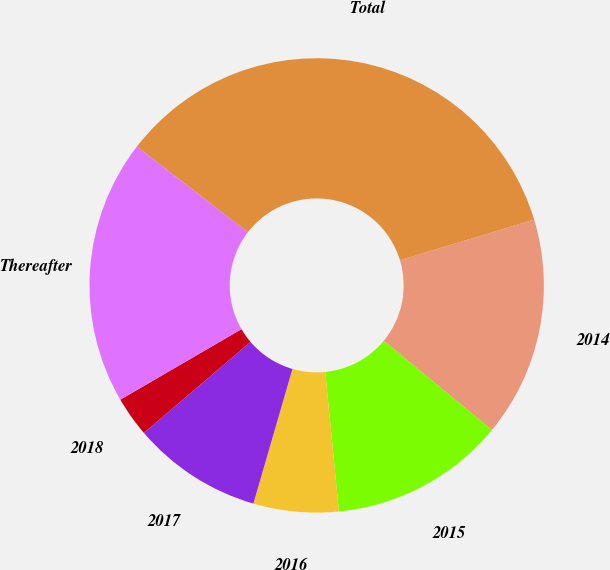Convert chart to OTSL. <chart><loc_0><loc_0><loc_500><loc_500><pie_chart><fcel>2014<fcel>2015<fcel>2016<fcel>2017<fcel>2018<fcel>Thereafter<fcel>Total<nl><fcel>15.66%<fcel>12.46%<fcel>6.06%<fcel>9.26%<fcel>2.86%<fcel>18.86%<fcel>34.85%<nl></chart> 